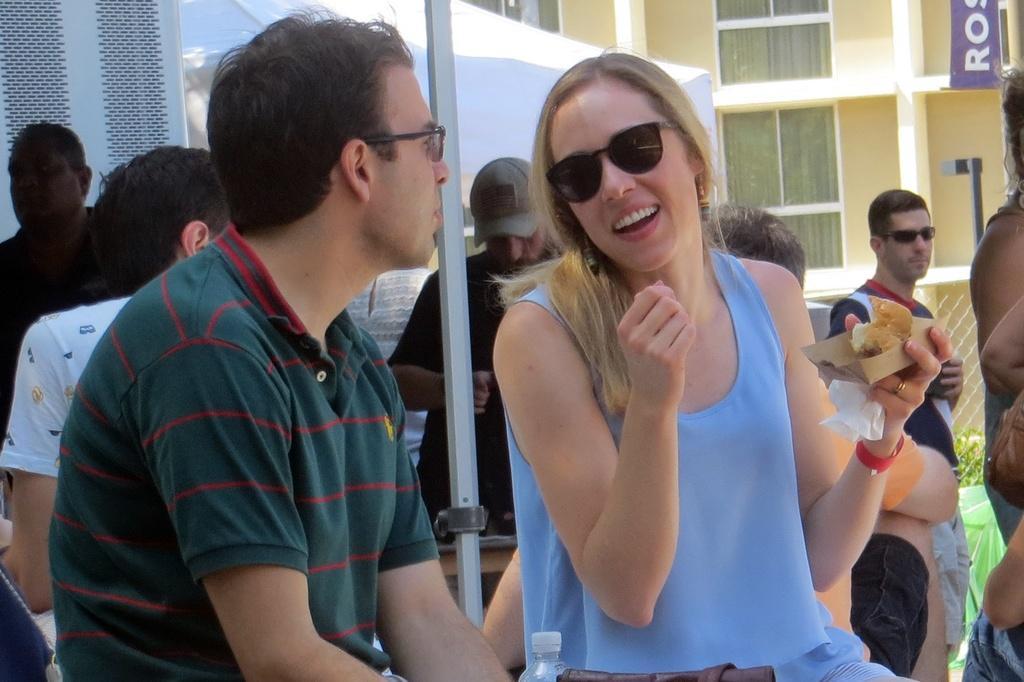Can you describe this image briefly? In this image there is a person wearing spectacles. Beside him there is a woman holding a paper which is having some food. Behind them there is a pole. Behind it there are few persons. Left side there is a tent. Behind there is a building. Before it there is a fence. Behind the fence there are few plants. 